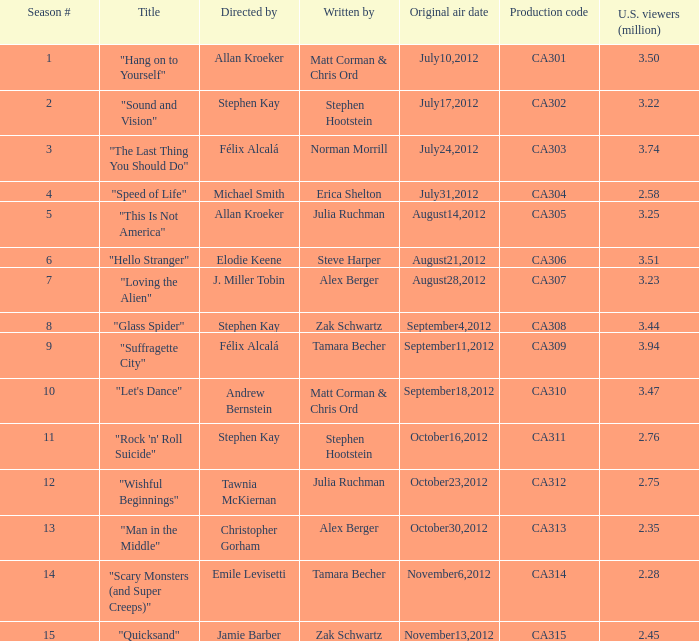What is the series episode number of the episode titled "sound and vision"? 29.0. 